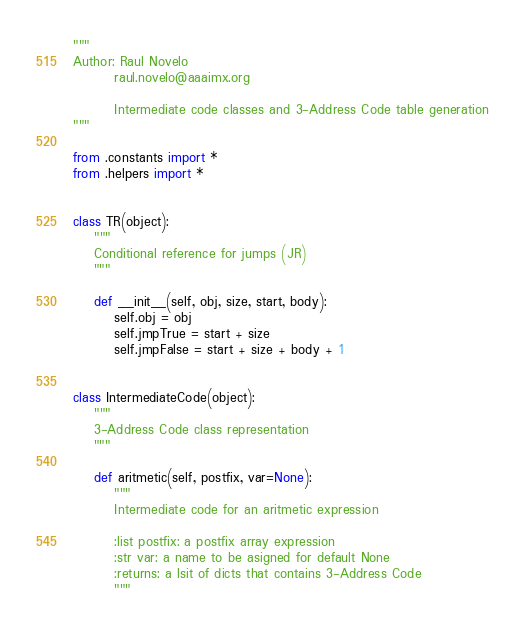<code> <loc_0><loc_0><loc_500><loc_500><_Python_>
"""
Author: Raul Novelo
        raul.novelo@aaaimx.org

        Intermediate code classes and 3-Address Code table generation
"""

from .constants import *
from .helpers import *


class TR(object):
    """
    Conditional reference for jumps (JR)
    """

    def __init__(self, obj, size, start, body):
        self.obj = obj
        self.jmpTrue = start + size
        self.jmpFalse = start + size + body + 1


class IntermediateCode(object):
    """
    3-Address Code class representation
    """

    def aritmetic(self, postfix, var=None):
        """
        Intermediate code for an aritmetic expression

        :list postfix: a postfix array expression
        :str var: a name to be asigned for default None
        :returns: a lsit of dicts that contains 3-Address Code
        """</code> 